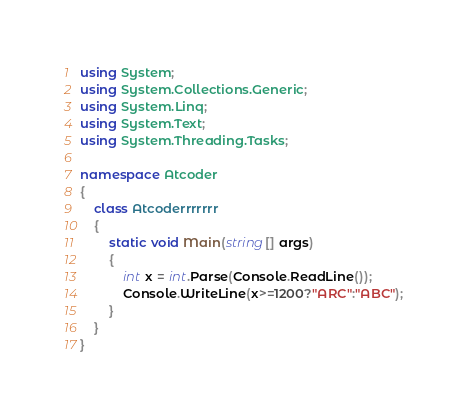<code> <loc_0><loc_0><loc_500><loc_500><_C#_>using System;
using System.Collections.Generic;
using System.Linq;
using System.Text;
using System.Threading.Tasks;

namespace Atcoder
{
    class Atcoderrrrrrr
    {
        static void Main(string[] args)
        {
            int x = int.Parse(Console.ReadLine());
            Console.WriteLine(x>=1200?"ARC":"ABC");
        }
    }
}
</code> 